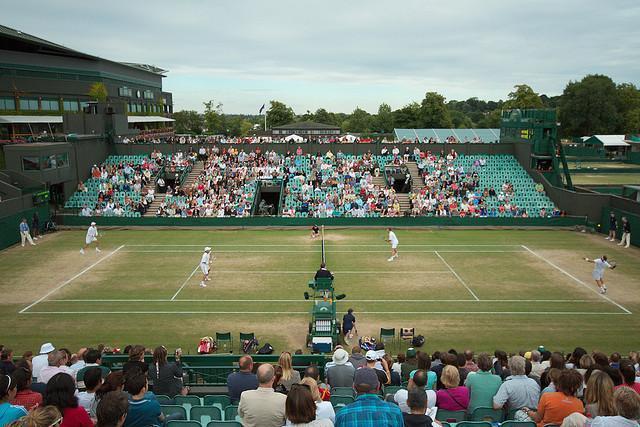How many people are there?
Give a very brief answer. 2. 